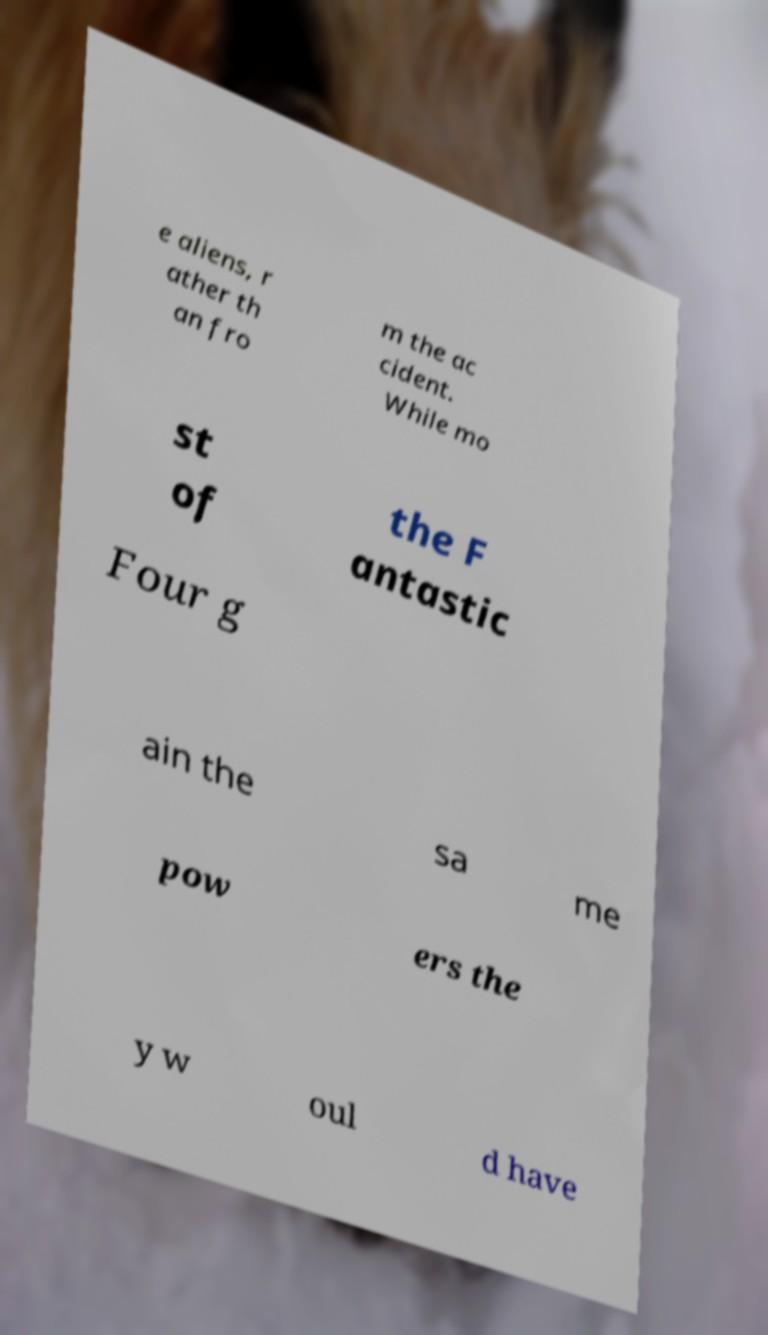Please read and relay the text visible in this image. What does it say? e aliens, r ather th an fro m the ac cident. While mo st of the F antastic Four g ain the sa me pow ers the y w oul d have 